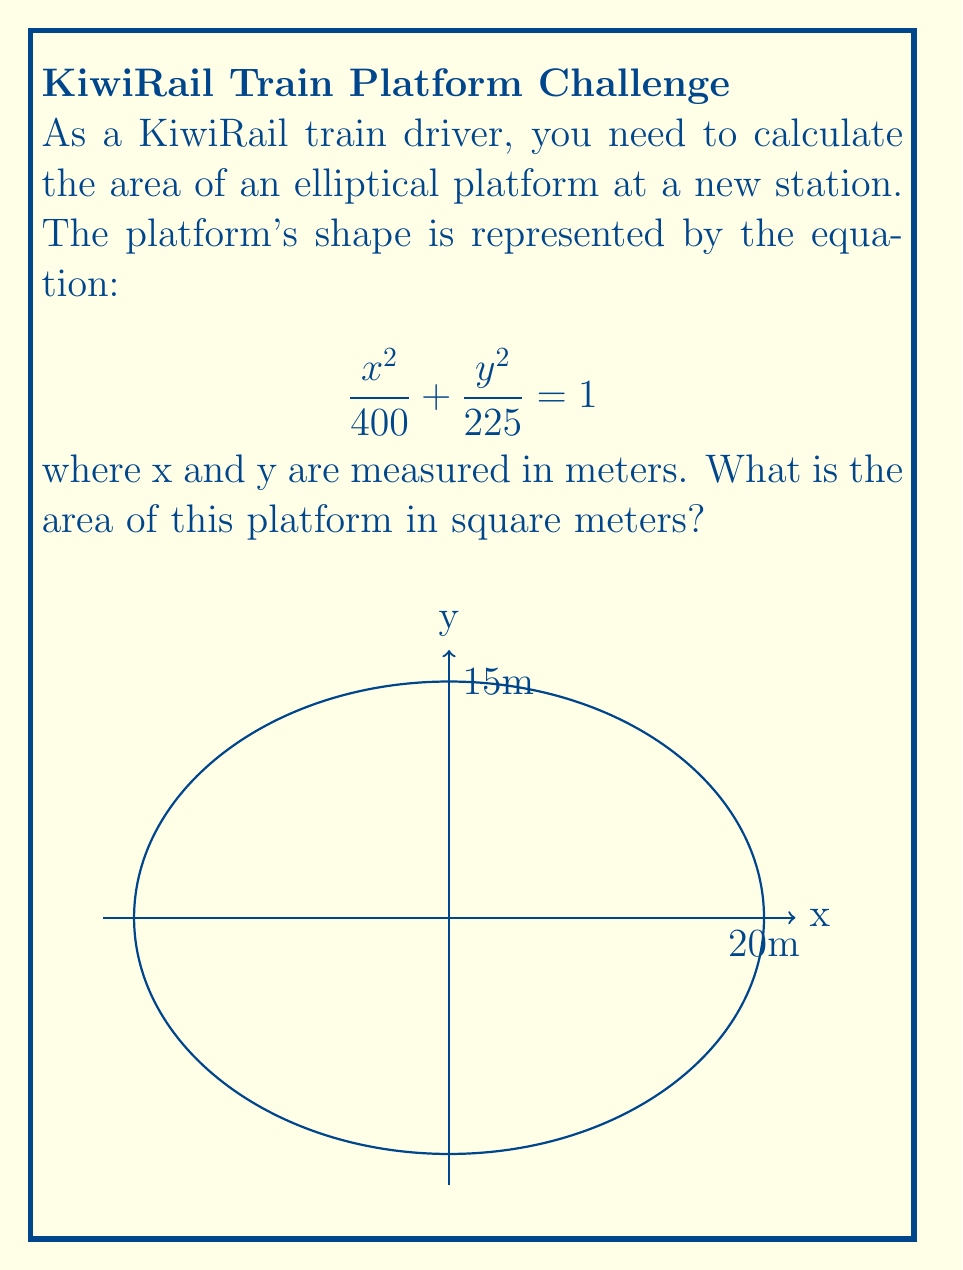Can you answer this question? To solve this problem, we'll follow these steps:

1) Recognize the standard form of an ellipse equation:
   $$\frac{x^2}{a^2} + \frac{y^2}{b^2} = 1$$
   where $a$ and $b$ are the semi-major and semi-minor axes.

2) Identify $a$ and $b$ from our equation:
   $$\frac{x^2}{400} + \frac{y^2}{225} = 1$$
   $a^2 = 400$, so $a = 20$ meters
   $b^2 = 225$, so $b = 15$ meters

3) Recall the formula for the area of an ellipse:
   $$A = \pi ab$$

4) Substitute the values:
   $$A = \pi (20)(15)$$

5) Calculate:
   $$A = 300\pi$$

Therefore, the area of the elliptical platform is $300\pi$ square meters.
Answer: $300\pi$ m² 